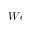Convert formula to latex. <formula><loc_0><loc_0><loc_500><loc_500>W e</formula> 